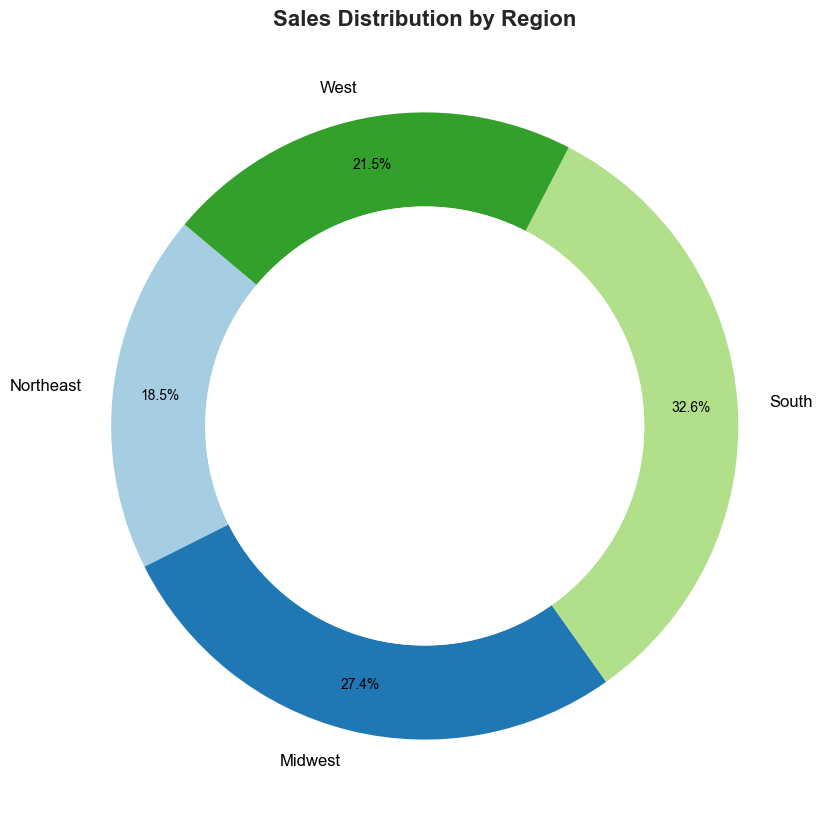Which region has the highest sales? By observing the ring chart, the slice representing the South is the largest among the four regions, indicating the highest sales.
Answer: South Which region has the lowest sales? By observing the ring chart, the slice representing the Northeast is the smallest among the four regions, indicating the lowest sales.
Answer: Northeast What percentage of total sales is from the Midwest region? The ring chart shows each region's sales percentage. By looking at the Midwest section, it displays "30.6%", which is the percentage of total sales from the Midwest.
Answer: 30.6% How do the sales of the West region compare to the South region? By observing the ring chart, the South region has a larger slice indicating higher sales, and the percentage for the South is 36.4%, whereas for the West it is 24.0%. Therefore, the South region has higher sales than the West region.
Answer: South has higher sales What is the difference in sales between the South and Northeast regions? From the figure, the South has 22,000 sales and the Northeast has 12,500 sales. The difference is calculated as 22,000 - 12,500.
Answer: 9,500 Which two regions combined account for over half of the total sales? By checking the percentages on the ring chart, the South (36.4%) and the Midwest (30.6%) combined equal 67.0%. They account for more than half of the total sales together.
Answer: South and Midwest What portion of sales does the West region occupy? From the ring chart, the slice representing the West region shows 24.0%, which is the portion of total sales for the West.
Answer: 24.0% Is the sales difference between the South and the Midwest greater or less than 5,000? The South region has 22,000 sales, and the Midwest has 18,500 sales. The difference is 22,000 - 18,500 = 3,500, which is less than 5,000.
Answer: Less than 5,000 What is the combined sales of the Northeast and West regions? From the ring chart, the Northeast has 12,500 sales and the West has 14,500 sales. Adding them together gives 12,500 + 14,500 = 27,000 sales.
Answer: 27,000 What color represents the South region on the chart? By looking at the ring chart, the slice representing the South region can be visually identified by its color.
Answer: (Color description from chart) 